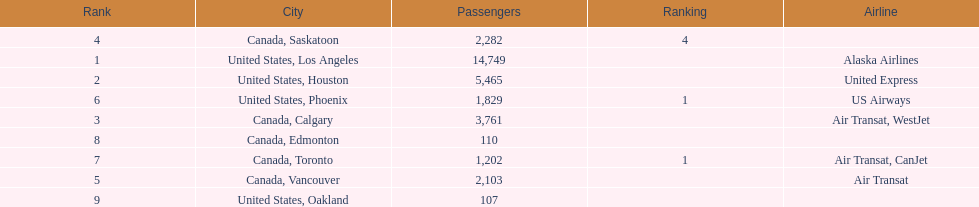How many airlines have a steady ranking? 4. 